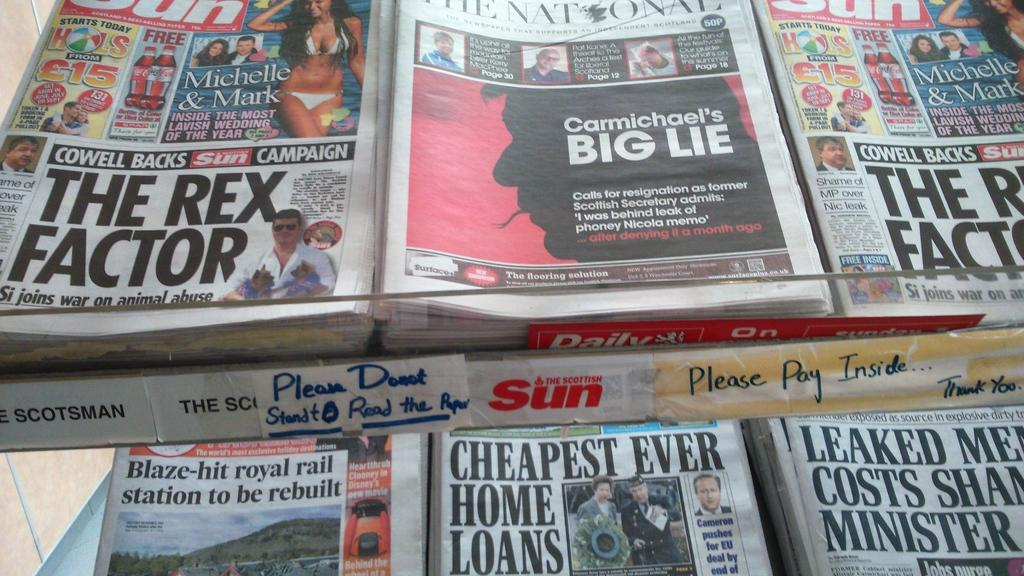<image>
Give a short and clear explanation of the subsequent image. Cheapest ever home loans magazine and The scottish sun red logo. 